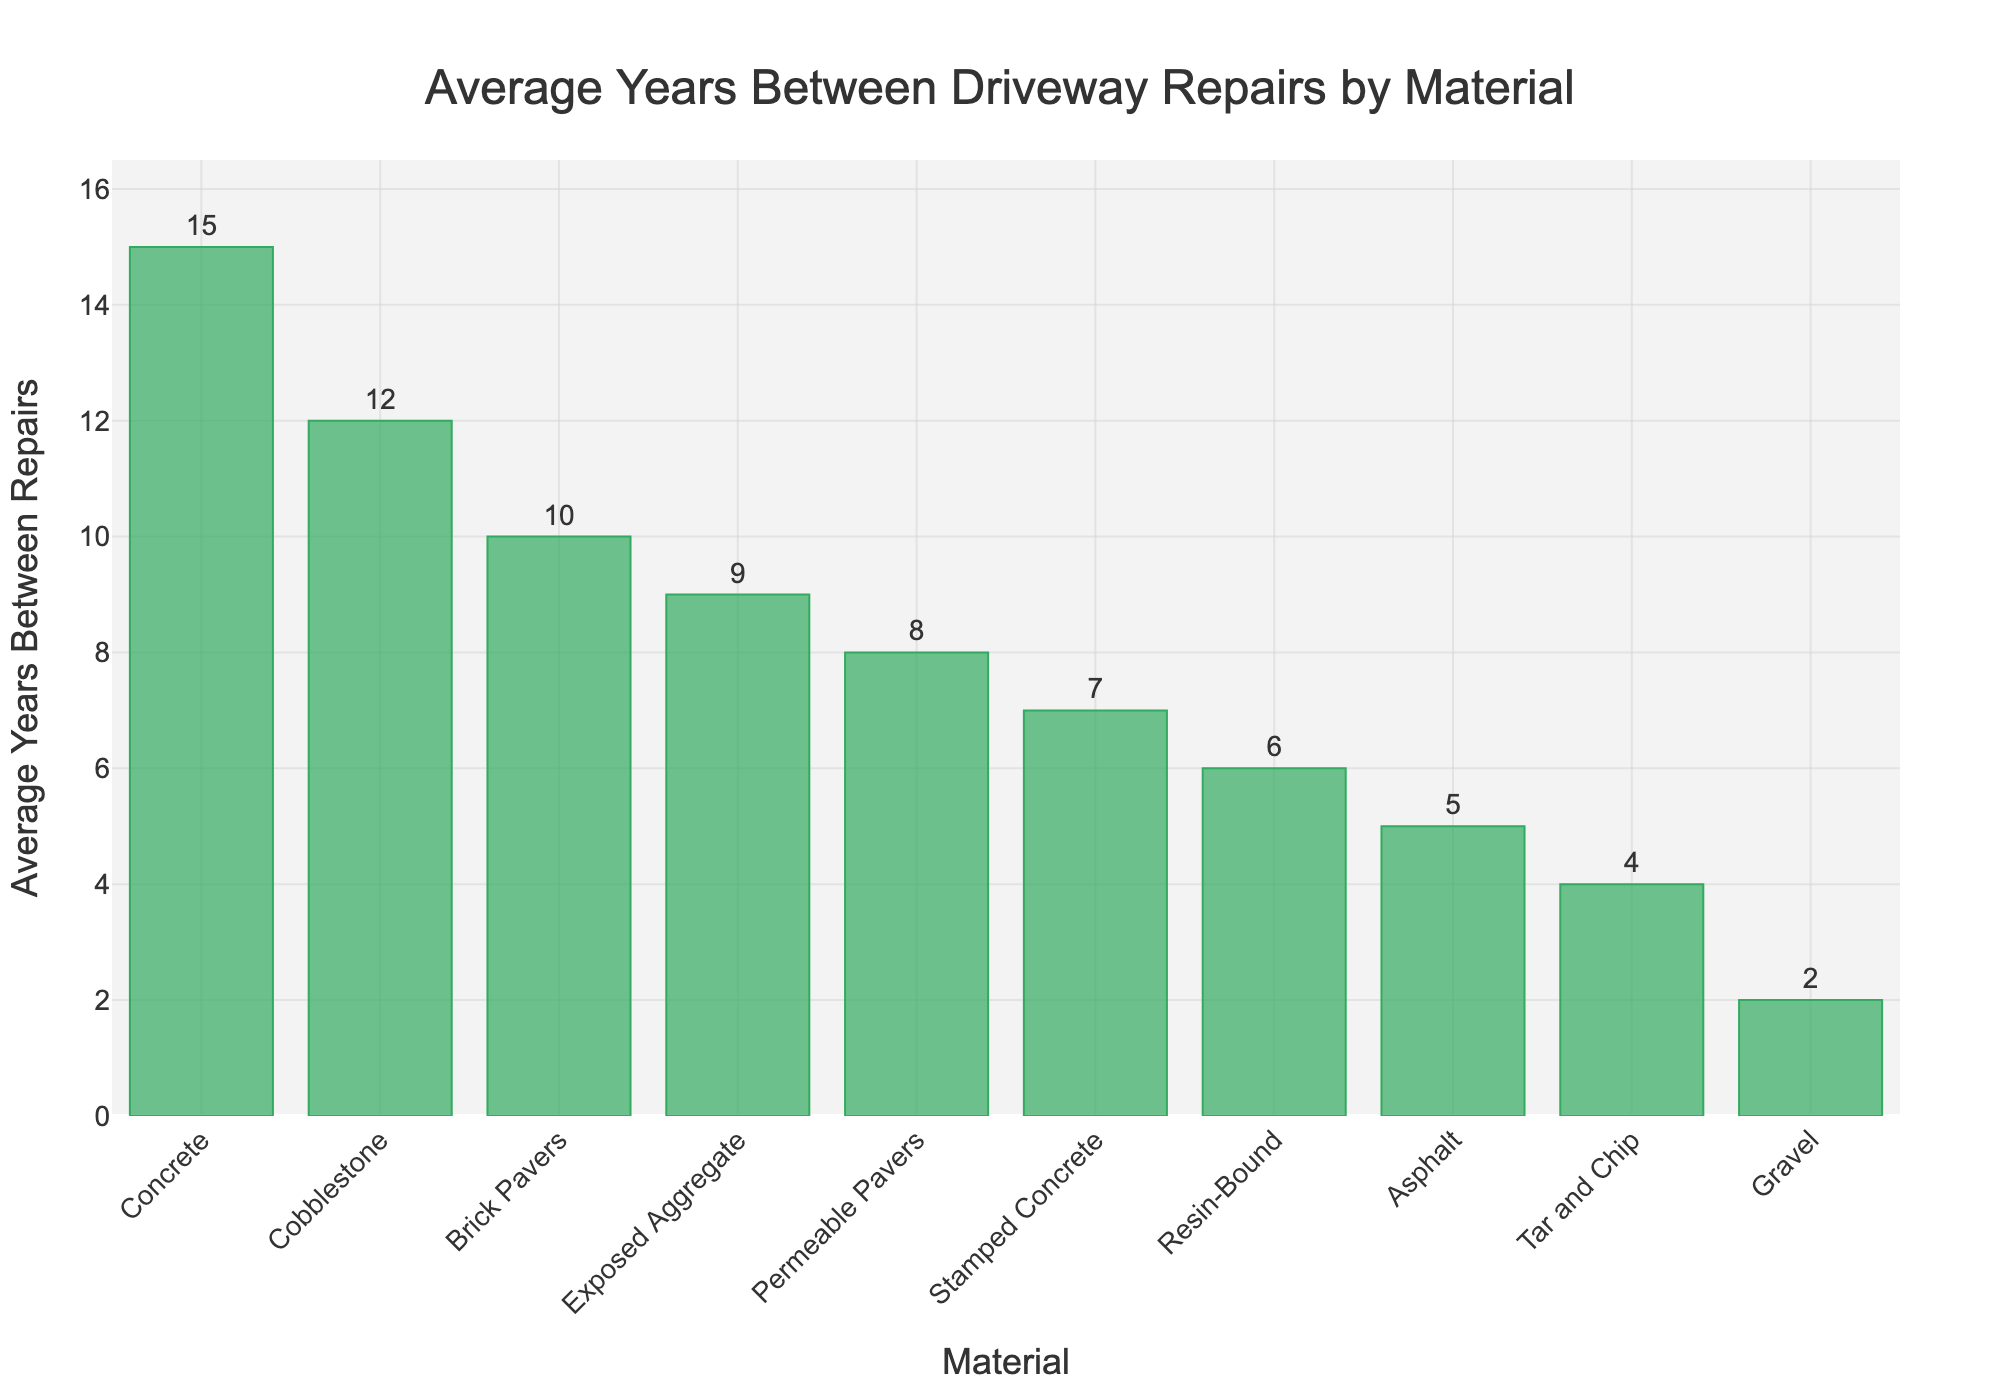Which material requires the frequent repairs? The material with the lowest average years between repairs will require the most frequent repairs. In this case, Gravel requires repairs every 2 years, which is the lowest among all materials.
Answer: Gravel Which driveway material has the longest time between repairs? The material with the highest average years between repairs will have the longest time between repairs. In this case, Concrete lasts 15 years before needing repairs, which is the highest among all materials.
Answer: Concrete How does Asphalt compare to Concrete in terms of average years between repairs? Asphalt has an average of 5 years between repairs while Concrete has 15 years. Comparing the two, Concrete lasts 10 years longer than Asphalt before needing repairs.
Answer: Concrete lasts 10 years longer than Asphalt Which material lasts longer, Resin-Bound or Permeable Pavers? Resin-Bound has an average of 6 years between repairs, while Permeable Pavers have 8 years. Permeable Pavers last 2 years longer than Resin-Bound.
Answer: Permeable Pavers What is the total average years between repairs for Gravel, Tar and Chip, and Stamped Concrete combined? Sum the average years between repairs for Gravel (2), Tar and Chip (4), and Stamped Concrete (7). The total is 2 + 4 + 7 = 13.
Answer: 13 What is the difference in years between the longest-lasting and shortest-lasting materials? The longest-lasting material is Concrete with 15 years, and the shortest-lasting material is Gravel with 2 years. The difference is 15 - 2 = 13 years.
Answer: 13 years Which materials have an average of at least 10 years between repairs? The materials with at least 10 years between repairs are Concrete (15), Brick Pavers (10), and Cobblestone (12).
Answer: Concrete, Brick Pavers, Cobblestone What is the median average years between repairs for all the materials listed? Arrange the years in ascending order: 2, 4, 5, 6, 7, 8, 9, 10, 12, 15. The median is the average of the 5th and 6th values in the sorted list, which is (7 + 8)/2 = 7.5.
Answer: 7.5 By how many years does Exposed Aggregate last longer than Tar and Chip? Exposed Aggregate lasts 9 years while Tar and Chip lasts 4 years, so Exposed Aggregate lasts 9 - 4 = 5 years longer than Tar and Chip.
Answer: 5 years Which driveway material falls just below Brick Pavers in terms of average years between repairs? Cobblestone with 12 years falls just below Brick Pavers with 10 years in the bar chart.
Answer: Cobblestone 